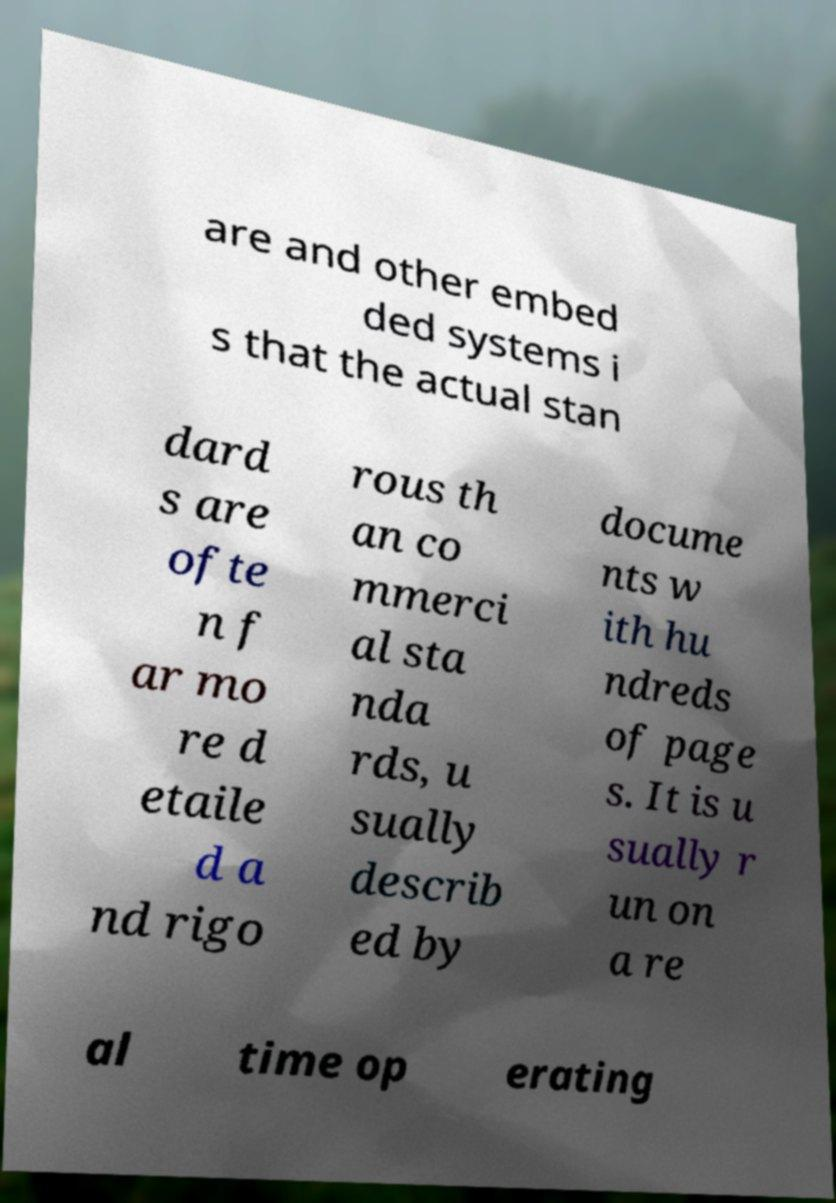Please identify and transcribe the text found in this image. are and other embed ded systems i s that the actual stan dard s are ofte n f ar mo re d etaile d a nd rigo rous th an co mmerci al sta nda rds, u sually describ ed by docume nts w ith hu ndreds of page s. It is u sually r un on a re al time op erating 